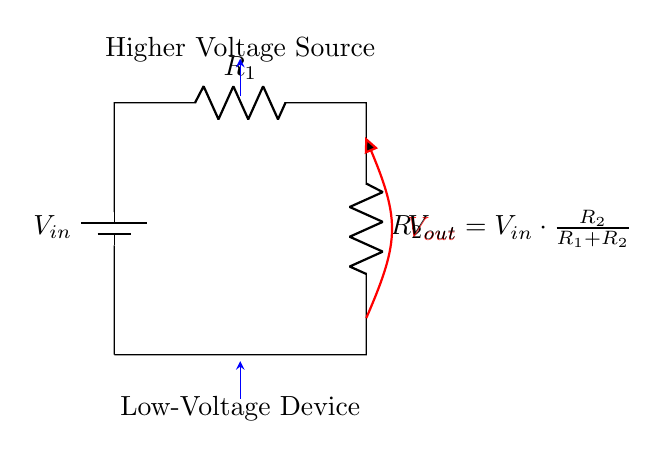What is the input voltage denoted as in the circuit? The input voltage is represented by the label V_in in the circuit diagram.
Answer: V_in What two resistors are present in this circuit? The resistors in the circuit are labeled as R_1 and R_2, which are depicted in series with the input voltage.
Answer: R_1, R_2 What is the formula used to calculate the output voltage? The output voltage formula depicted in the circuit is V_out = V_in times (R_2 divided by (R_1 + R_2)), as indicated by the written expression.
Answer: V_out = V_in * (R_2 / (R_1 + R_2)) What role do resistors R_1 and R_2 play in this circuit? In this voltage divider circuit, R_1 and R_2 work together to divide the input voltage, creating a lower output voltage for low-voltage devices.
Answer: Divide input voltage What happens to the output voltage if R_2 is increased? If R_2 is increased, the output voltage V_out will rise since it is proportional to R_2 in the division formula, leading to more voltage available for the low-voltage device.
Answer: V_out increases What is the connection type of the resistors in this circuit? The resistors R_1 and R_2 are connected in series, meaning they are aligned sequentially in the circuit pathway.
Answer: Series 